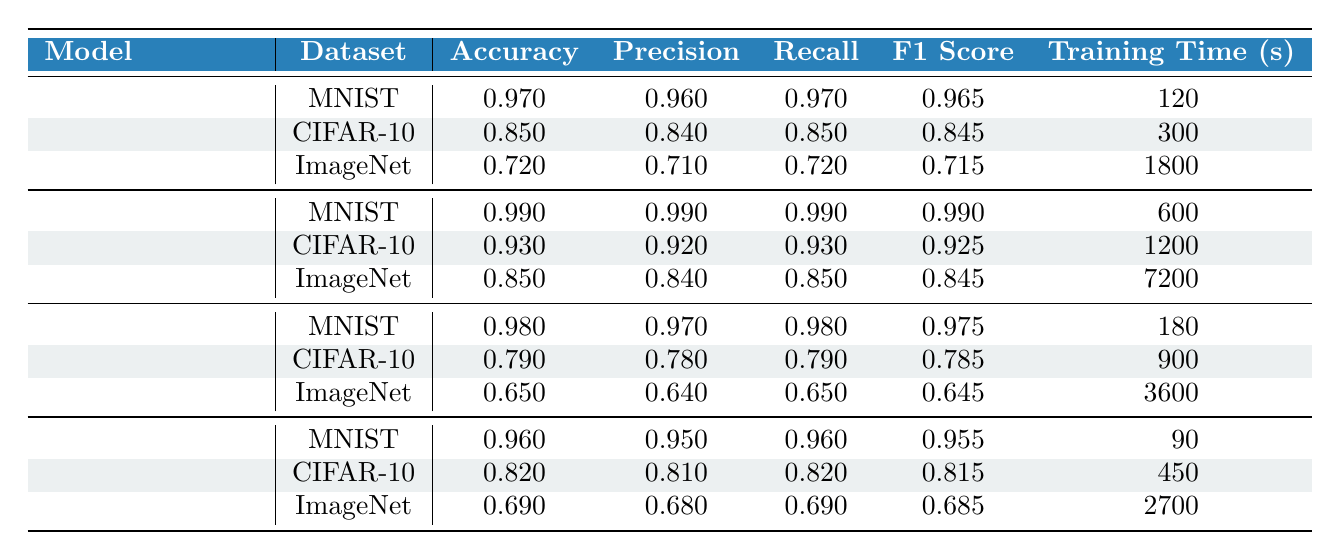What is the accuracy of the Convolutional Neural Network on the MNIST dataset? The table shows that the accuracy of the Convolutional Neural Network on the MNIST dataset is listed as 0.990.
Answer: 0.990 Which model has the highest F1 Score on the CIFAR-10 dataset? By examining the F1 Scores for all models on the CIFAR-10 dataset, the Convolutional Neural Network has an F1 Score of 0.925, which is higher than the other models' F1 Scores on the same dataset.
Answer: Convolutional Neural Network What is the average training time for Random Forest models across all datasets? The training times for Random Forest on the datasets are 120, 300, and 1800 seconds. The sum of these times is 2220 seconds. There are three datasets, so the average is 2220/3, which equals 740 seconds.
Answer: 740 Is the accuracy of the Support Vector Machine on ImageNet greater than that of the XGBoost model on the same dataset? The accuracy for the Support Vector Machine on ImageNet is 0.650, while the accuracy for XGBoost on ImageNet is 0.690. Since 0.650 is less than 0.690, the statement is false.
Answer: No What is the difference in accuracy between the XGBoost model on MNIST and the Support Vector Machine on CIFAR-10? The accuracy of XGBoost on MNIST is 0.960, while the accuracy of Support Vector Machine on CIFAR-10 is 0.790. The difference is 0.960 - 0.790 = 0.170.
Answer: 0.170 Which model shows the longest training time across all datasets? The table shows the training times for each model across its respective datasets. The longest time is 7200 seconds for the Convolutional Neural Network on ImageNet, which is greater than the training times of the other models.
Answer: Convolutional Neural Network What is the precision of the Random Forest model on the CIFAR-10 dataset? Looking at the table, the precision of the Random Forest model on the CIFAR-10 dataset is listed as 0.840.
Answer: 0.840 Is the F1 Score of the Support Vector Machine on MNIST greater than 0.90? The F1 Score for the Support Vector Machine on MNIST is 0.975, which is indeed greater than 0.90. Therefore, the statement is true.
Answer: Yes What is the median recall score across all models on the MNIST dataset? The recall scores for the models on MNIST are 0.970 for Random Forest, 0.990 for Convolutional Neural Network, and 0.980 for Support Vector Machine. Sorting these values gives us 0.970, 0.980, and 0.990. The median of these three numbers is the middle value, which is 0.980.
Answer: 0.980 